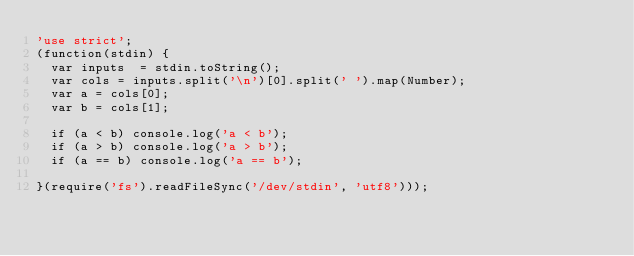<code> <loc_0><loc_0><loc_500><loc_500><_JavaScript_>'use strict';
(function(stdin) {
  var inputs  = stdin.toString();
  var cols = inputs.split('\n')[0].split(' ').map(Number);
  var a = cols[0];
  var b = cols[1];

  if (a < b) console.log('a < b'); 
  if (a > b) console.log('a > b'); 
  if (a == b) console.log('a == b');

}(require('fs').readFileSync('/dev/stdin', 'utf8')));</code> 